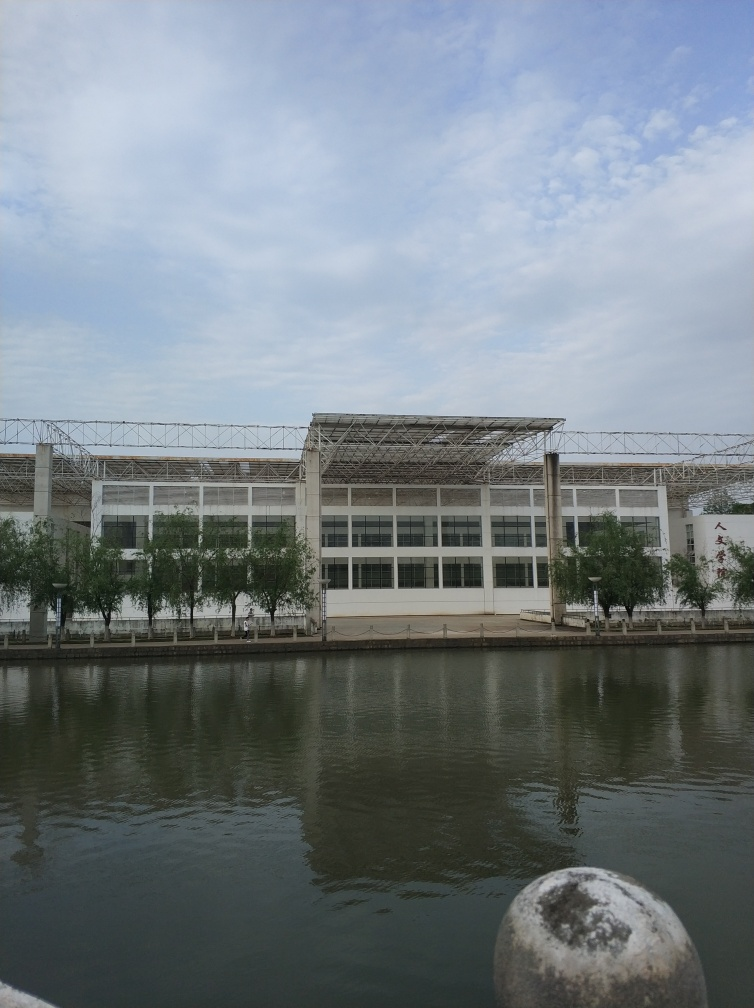Are the ripples on the water surface distinct? Yes, the ripples are distinct. The water surface shows a pattern of gentle undulations which indicates a light breeze or small movements in the water, creating visible ripples across the surface. 